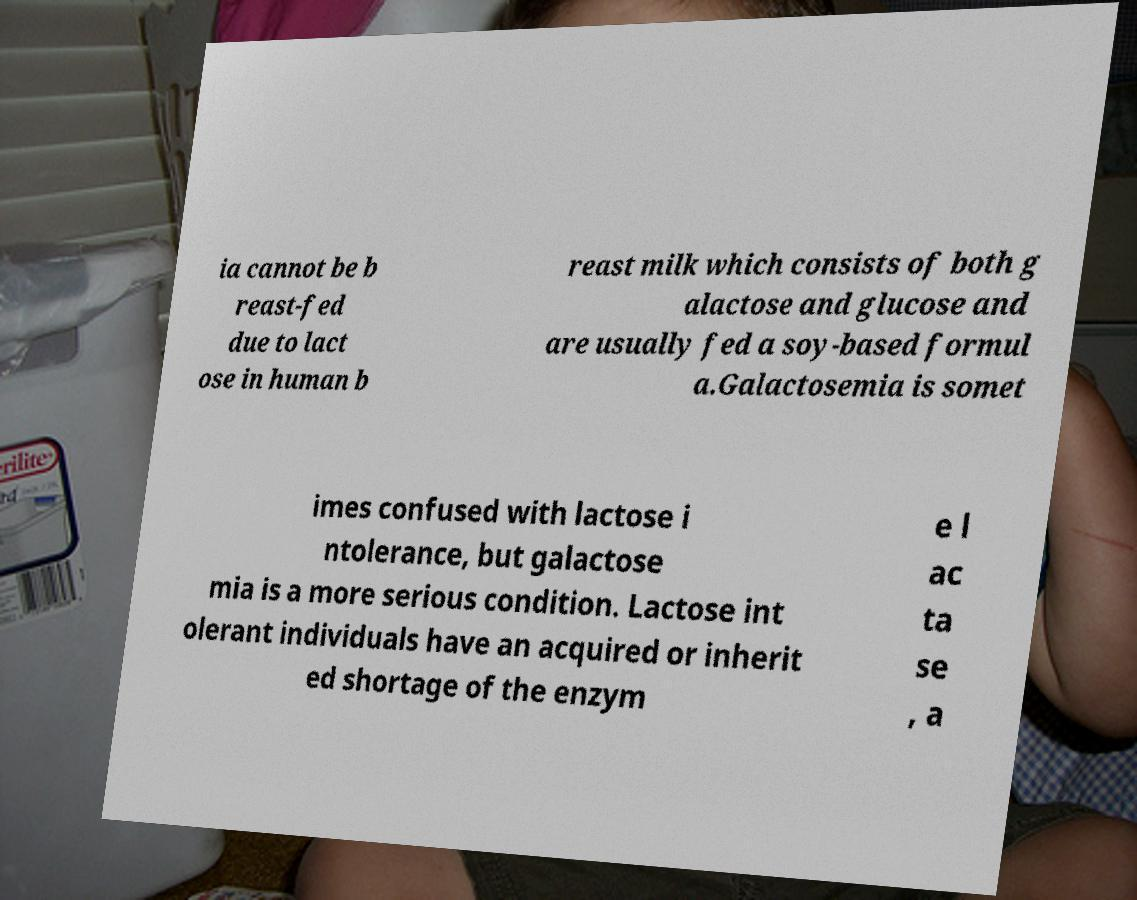For documentation purposes, I need the text within this image transcribed. Could you provide that? ia cannot be b reast-fed due to lact ose in human b reast milk which consists of both g alactose and glucose and are usually fed a soy-based formul a.Galactosemia is somet imes confused with lactose i ntolerance, but galactose mia is a more serious condition. Lactose int olerant individuals have an acquired or inherit ed shortage of the enzym e l ac ta se , a 